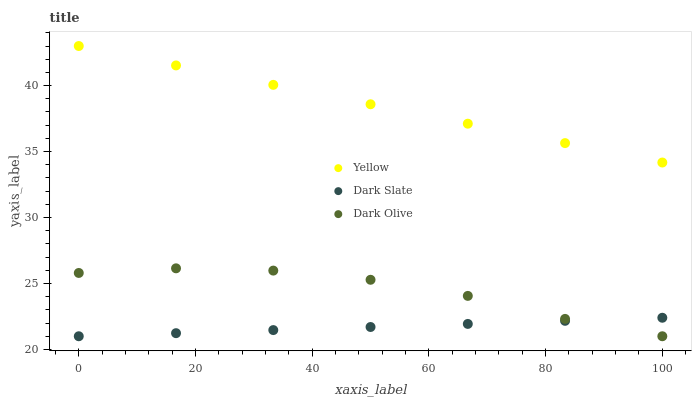Does Dark Slate have the minimum area under the curve?
Answer yes or no. Yes. Does Yellow have the maximum area under the curve?
Answer yes or no. Yes. Does Dark Olive have the minimum area under the curve?
Answer yes or no. No. Does Dark Olive have the maximum area under the curve?
Answer yes or no. No. Is Dark Slate the smoothest?
Answer yes or no. Yes. Is Dark Olive the roughest?
Answer yes or no. Yes. Is Yellow the smoothest?
Answer yes or no. No. Is Yellow the roughest?
Answer yes or no. No. Does Dark Slate have the lowest value?
Answer yes or no. Yes. Does Yellow have the lowest value?
Answer yes or no. No. Does Yellow have the highest value?
Answer yes or no. Yes. Does Dark Olive have the highest value?
Answer yes or no. No. Is Dark Slate less than Yellow?
Answer yes or no. Yes. Is Yellow greater than Dark Olive?
Answer yes or no. Yes. Does Dark Olive intersect Dark Slate?
Answer yes or no. Yes. Is Dark Olive less than Dark Slate?
Answer yes or no. No. Is Dark Olive greater than Dark Slate?
Answer yes or no. No. Does Dark Slate intersect Yellow?
Answer yes or no. No. 